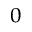Convert formula to latex. <formula><loc_0><loc_0><loc_500><loc_500>_ { 0 }</formula> 